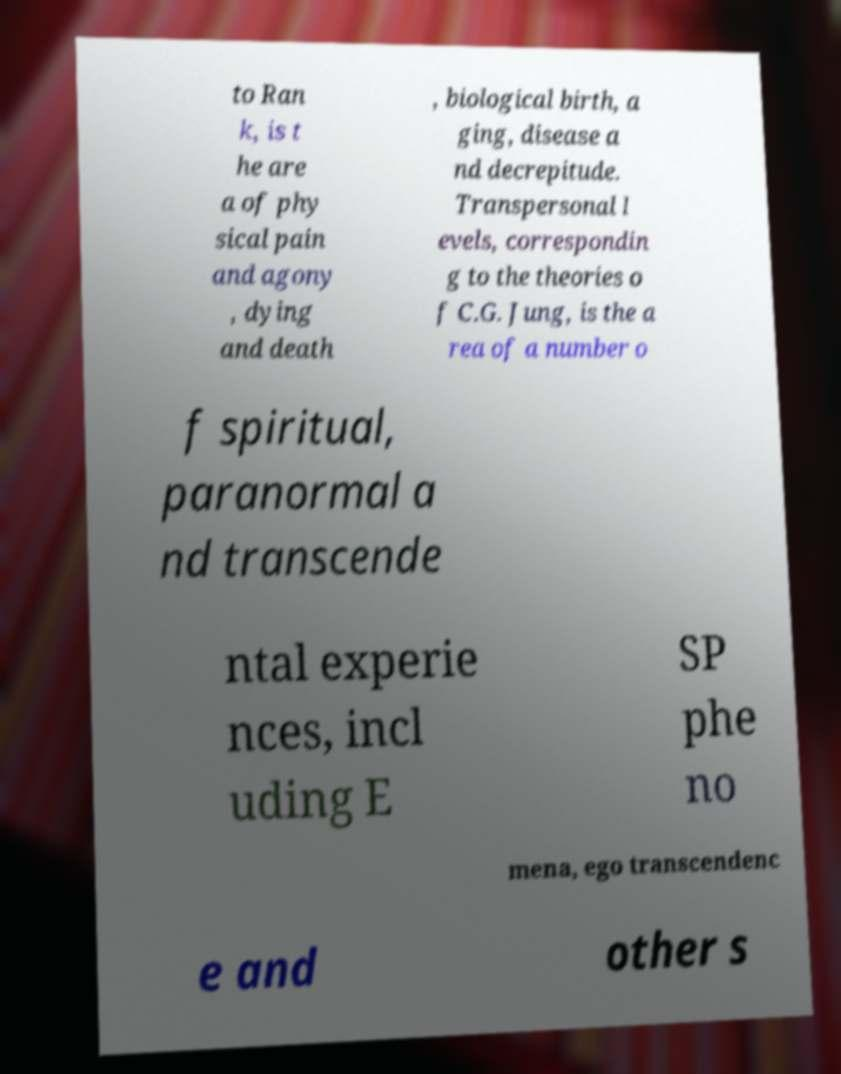Could you assist in decoding the text presented in this image and type it out clearly? to Ran k, is t he are a of phy sical pain and agony , dying and death , biological birth, a ging, disease a nd decrepitude. Transpersonal l evels, correspondin g to the theories o f C.G. Jung, is the a rea of a number o f spiritual, paranormal a nd transcende ntal experie nces, incl uding E SP phe no mena, ego transcendenc e and other s 